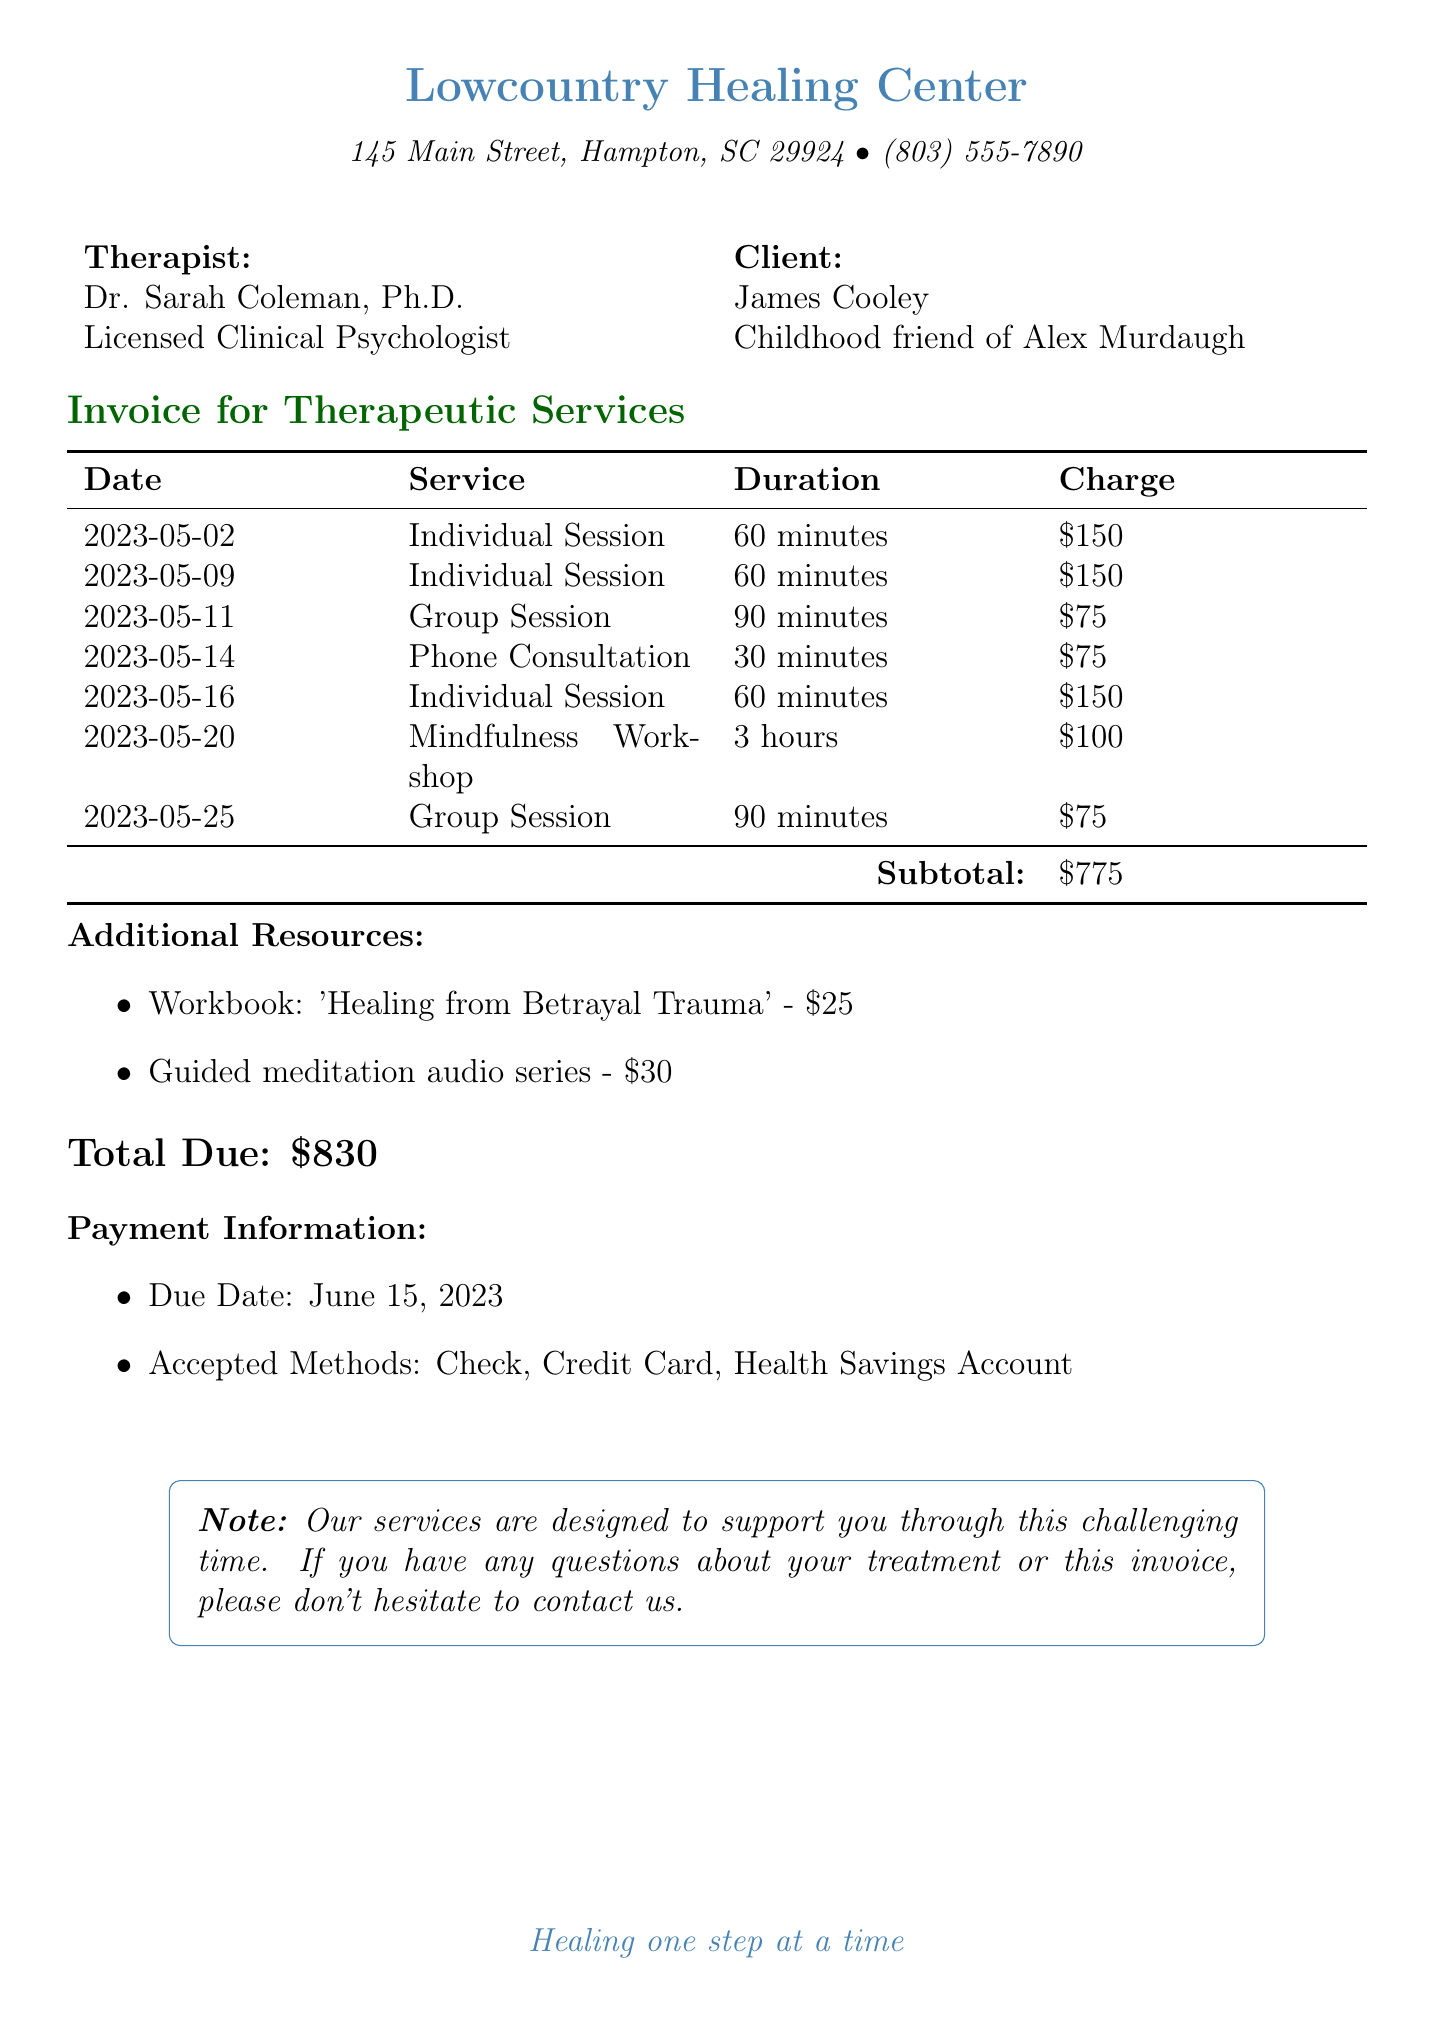what is the name of the therapist? The document lists Dr. Sarah Coleman as the therapist providing the services.
Answer: Dr. Sarah Coleman what is the charge for the mindfulness workshop? The document specifies that the mindfulness and stress reduction workshop charge is $100.
Answer: $100 how many individual therapy sessions are listed? The document includes three individual therapy sessions, each detailed with date and focus.
Answer: 3 what is the total amount due for the services? The total charges for services, including therapy sessions and additional resources, is indicated as $830.
Answer: $830 which service has the lowest charge? The phone consultation and group sessions are each charged at $75, which is the lowest amount mentioned.
Answer: $75 who facilitated the support group session? The document states that Dr. Michael Jenkins facilitated the group support sessions.
Answer: Dr. Michael Jenkins what is the due date for payment? The payment due date is explicitly stated as June 15, 2023.
Answer: June 15, 2023 how long was the longest individual session? The individual sessions are all 60 minutes long, which is the maximum duration mentioned for individual therapy.
Answer: 60 minutes what resources were provided in the invoice? The document lists a workbook and a guided meditation audio series as additional resources provided.
Answer: Workbook and Guided meditation audio series 